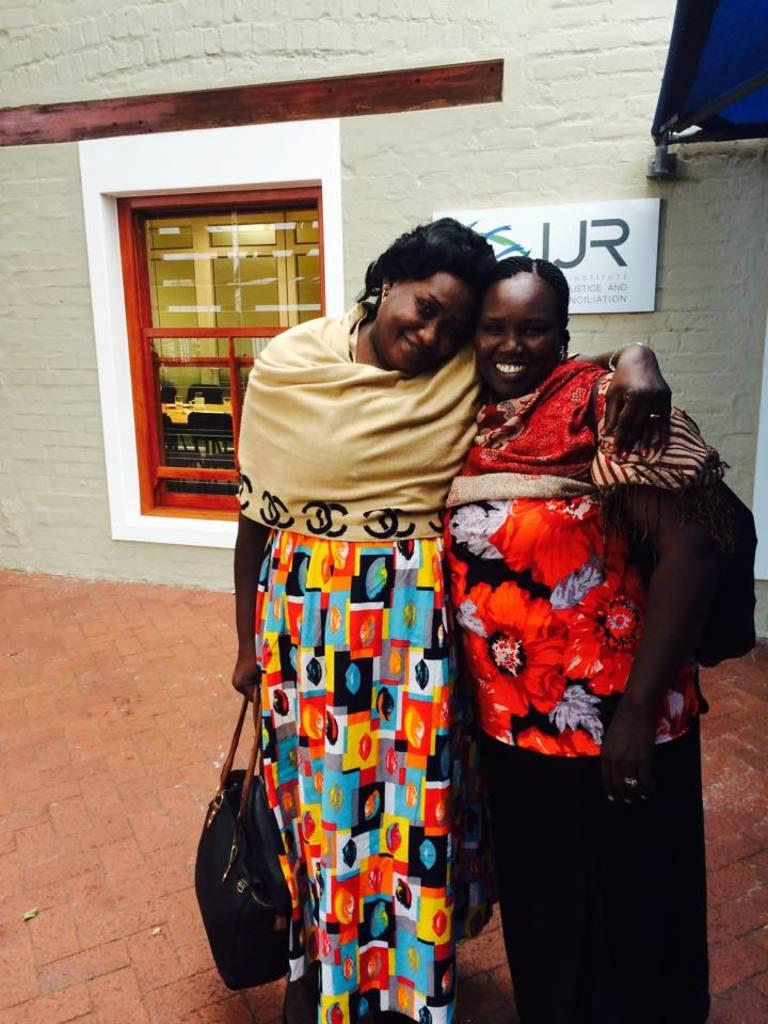How many women are in the image? There are two women in the image. What are the women doing in the image? The women are standing together and posing for the picture. What can be seen in the background of the image? There is a glass window and a light green wall in the background of the image. What type of flooring is visible in the image? There are bricks on the floor in the image. What advice are the women giving each other in the image? There is no indication in the image that the women are giving each other advice; they are simply posing for a picture. What type of teeth can be seen in the image? There are no teeth visible in the image. 